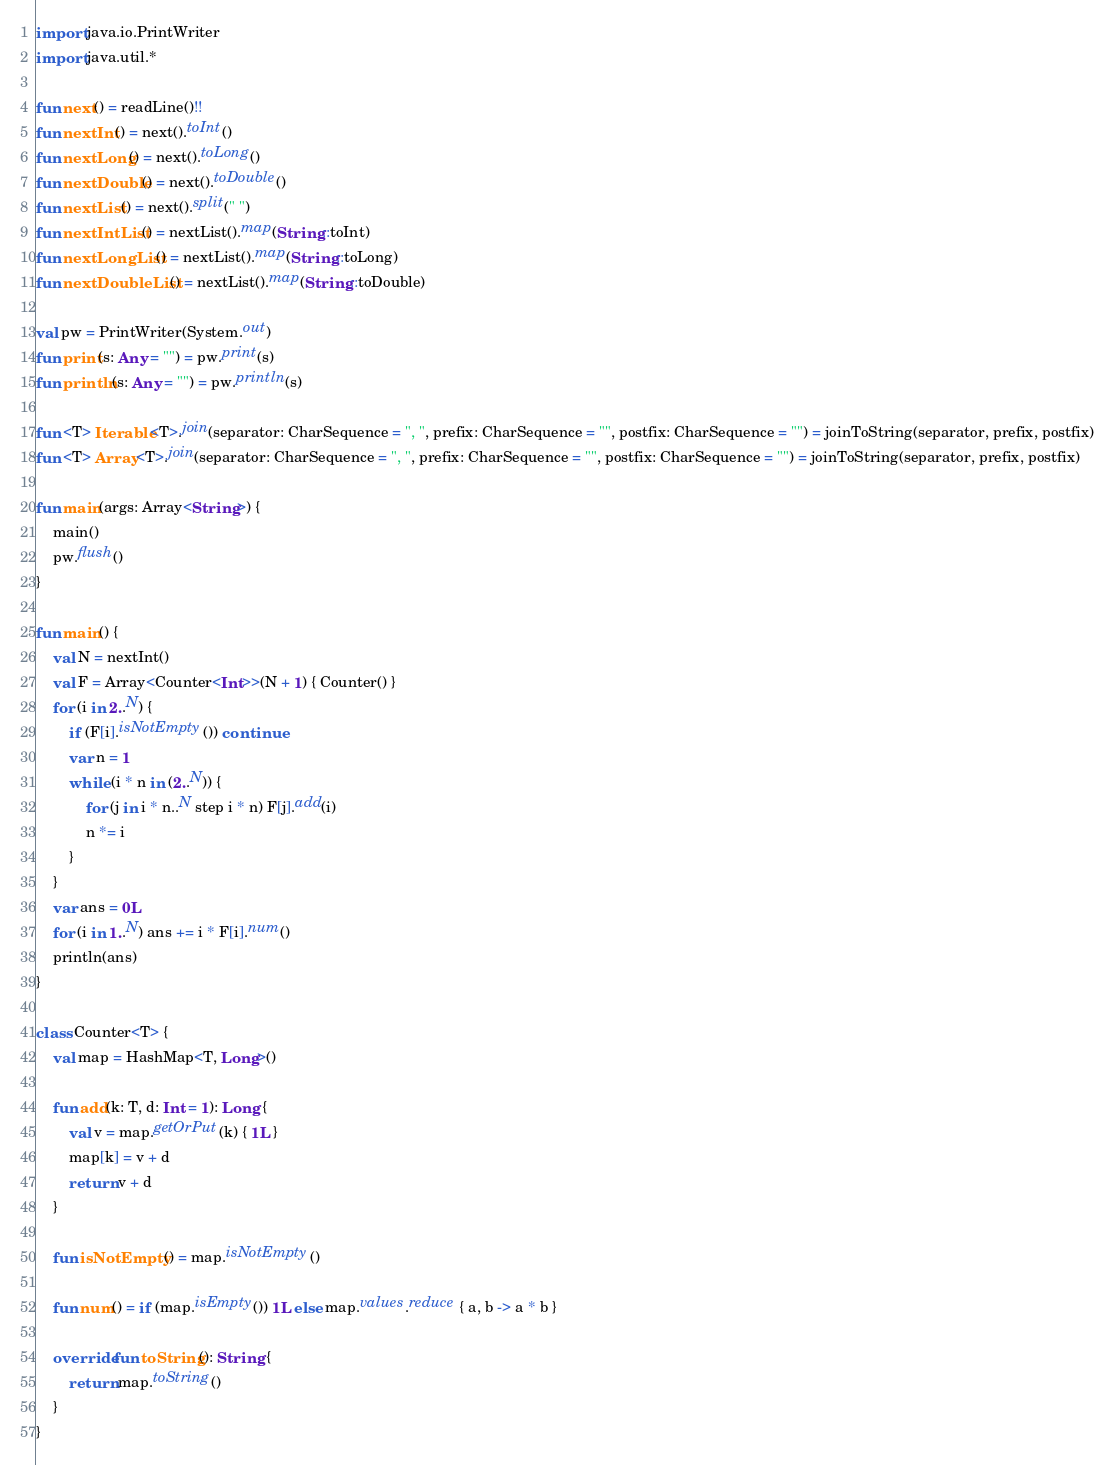Convert code to text. <code><loc_0><loc_0><loc_500><loc_500><_Kotlin_>import java.io.PrintWriter
import java.util.*

fun next() = readLine()!!
fun nextInt() = next().toInt()
fun nextLong() = next().toLong()
fun nextDouble() = next().toDouble()
fun nextList() = next().split(" ")
fun nextIntList() = nextList().map(String::toInt)
fun nextLongList() = nextList().map(String::toLong)
fun nextDoubleList() = nextList().map(String::toDouble)

val pw = PrintWriter(System.out)
fun print(s: Any = "") = pw.print(s)
fun println(s: Any = "") = pw.println(s)

fun <T> Iterable<T>.join(separator: CharSequence = ", ", prefix: CharSequence = "", postfix: CharSequence = "") = joinToString(separator, prefix, postfix)
fun <T> Array<T>.join(separator: CharSequence = ", ", prefix: CharSequence = "", postfix: CharSequence = "") = joinToString(separator, prefix, postfix)

fun main(args: Array<String>) {
    main()
    pw.flush()
}

fun main() {
    val N = nextInt()
    val F = Array<Counter<Int>>(N + 1) { Counter() }
    for (i in 2..N) {
        if (F[i].isNotEmpty()) continue
        var n = 1
        while (i * n in (2..N)) {
            for (j in i * n..N step i * n) F[j].add(i)
            n *= i
        }
    }
    var ans = 0L
    for (i in 1..N) ans += i * F[i].num()
    println(ans)
}

class Counter<T> {
    val map = HashMap<T, Long>()

    fun add(k: T, d: Int = 1): Long {
        val v = map.getOrPut(k) { 1L }
        map[k] = v + d
        return v + d
    }

    fun isNotEmpty() = map.isNotEmpty()

    fun num() = if (map.isEmpty()) 1L else map.values.reduce { a, b -> a * b }

    override fun toString(): String {
        return map.toString()
    }
}</code> 